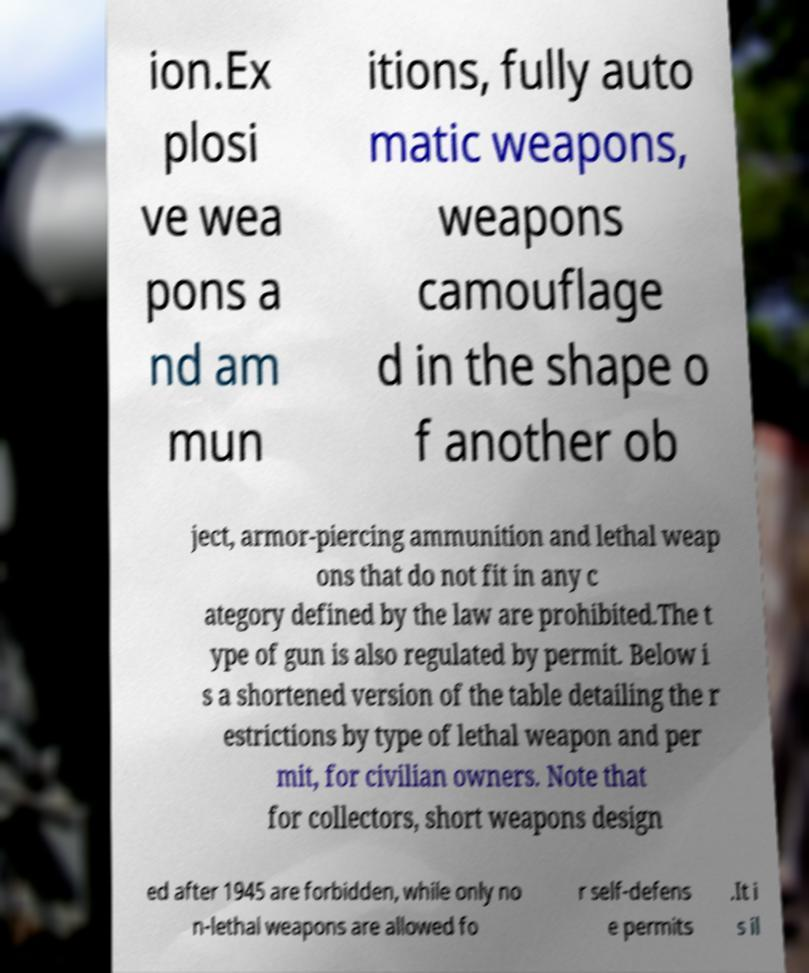Please read and relay the text visible in this image. What does it say? ion.Ex plosi ve wea pons a nd am mun itions, fully auto matic weapons, weapons camouflage d in the shape o f another ob ject, armor-piercing ammunition and lethal weap ons that do not fit in any c ategory defined by the law are prohibited.The t ype of gun is also regulated by permit. Below i s a shortened version of the table detailing the r estrictions by type of lethal weapon and per mit, for civilian owners. Note that for collectors, short weapons design ed after 1945 are forbidden, while only no n-lethal weapons are allowed fo r self-defens e permits .It i s il 